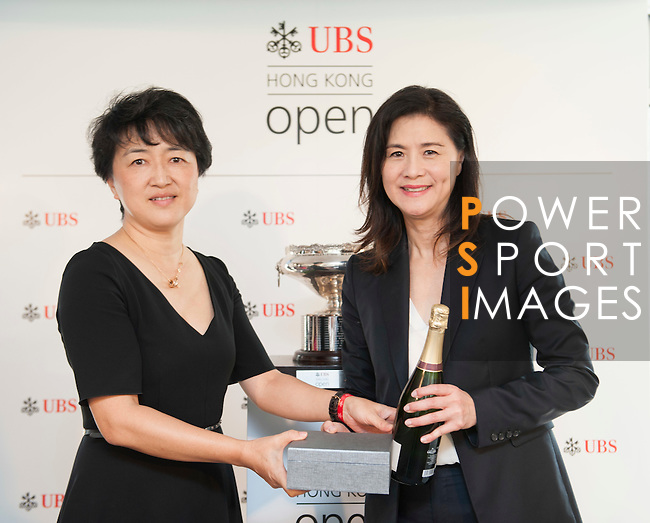Don't forget these rules:
 
1. **Be Direct and Concise**: Provide straightforward descriptions without adding interpretative or speculative elements.
2. **Use Segmented Details**: Break down details about different elements of an image into distinct sentences, focusing on one aspect at a time.
3. **Maintain a Descriptive Focus**: Prioritize purely visible elements of the image, avoiding conclusions or inferences.
4. **Follow a Logical Structure**: Begin with the central figure or subject and expand outward, detailing its appearance before addressing the surrounding setting.
5. **Avoid Juxtaposition**: Do not use comparison or contrast language; keep the description purely factual.
6. **Incorporate Specificity**: Mention age, gender, race, and specific brands or notable features when present, and clearly identify the medium if it's discernible. 
 
When writing descriptions, prioritize clarity and direct observation over embellishment or interpretation.
 
Write a detailed description of this image, do not forget about the texts on it if they exist. Also, do not forget to mention the type / style of the image. No bullet points. The image is a color photograph featuring two women positioned in front of a promotional backdrop. The backdrop includes logos for the "Hong Kong Open UBS" along with a watermark that reads "POWER SPORT IMAGES." Both women are posed smiling at the camera, each holding a part of a presentation box: the woman on the left is holding the base, while the woman on the right is holding the lid and a bottle of champagne. They are dressed in professional attire; the woman on the left in a black short-sleeve dress and the woman on the right in a dark blazer and white top. In the background, slightly out of focus, there is a silver trophy on a pedestal. The overall setting suggests that this is an event related to a sporting or competitive occasion, likely a ceremony for the Hong Kong Open. 